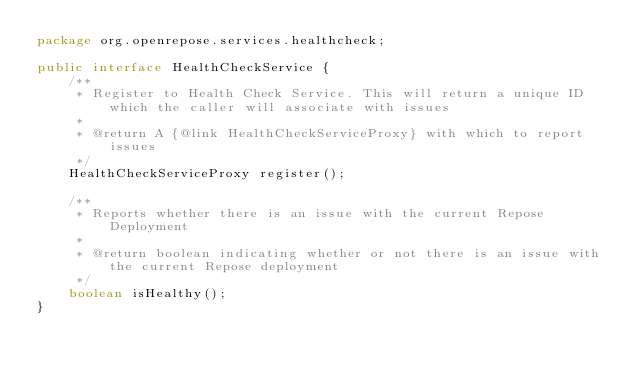<code> <loc_0><loc_0><loc_500><loc_500><_Java_>package org.openrepose.services.healthcheck;

public interface HealthCheckService {
    /**
     * Register to Health Check Service. This will return a unique ID which the caller will associate with issues
     *
     * @return A {@link HealthCheckServiceProxy} with which to report issues
     */
    HealthCheckServiceProxy register();

    /**
     * Reports whether there is an issue with the current Repose Deployment
     *
     * @return boolean indicating whether or not there is an issue with the current Repose deployment
     */
    boolean isHealthy();
}
</code> 